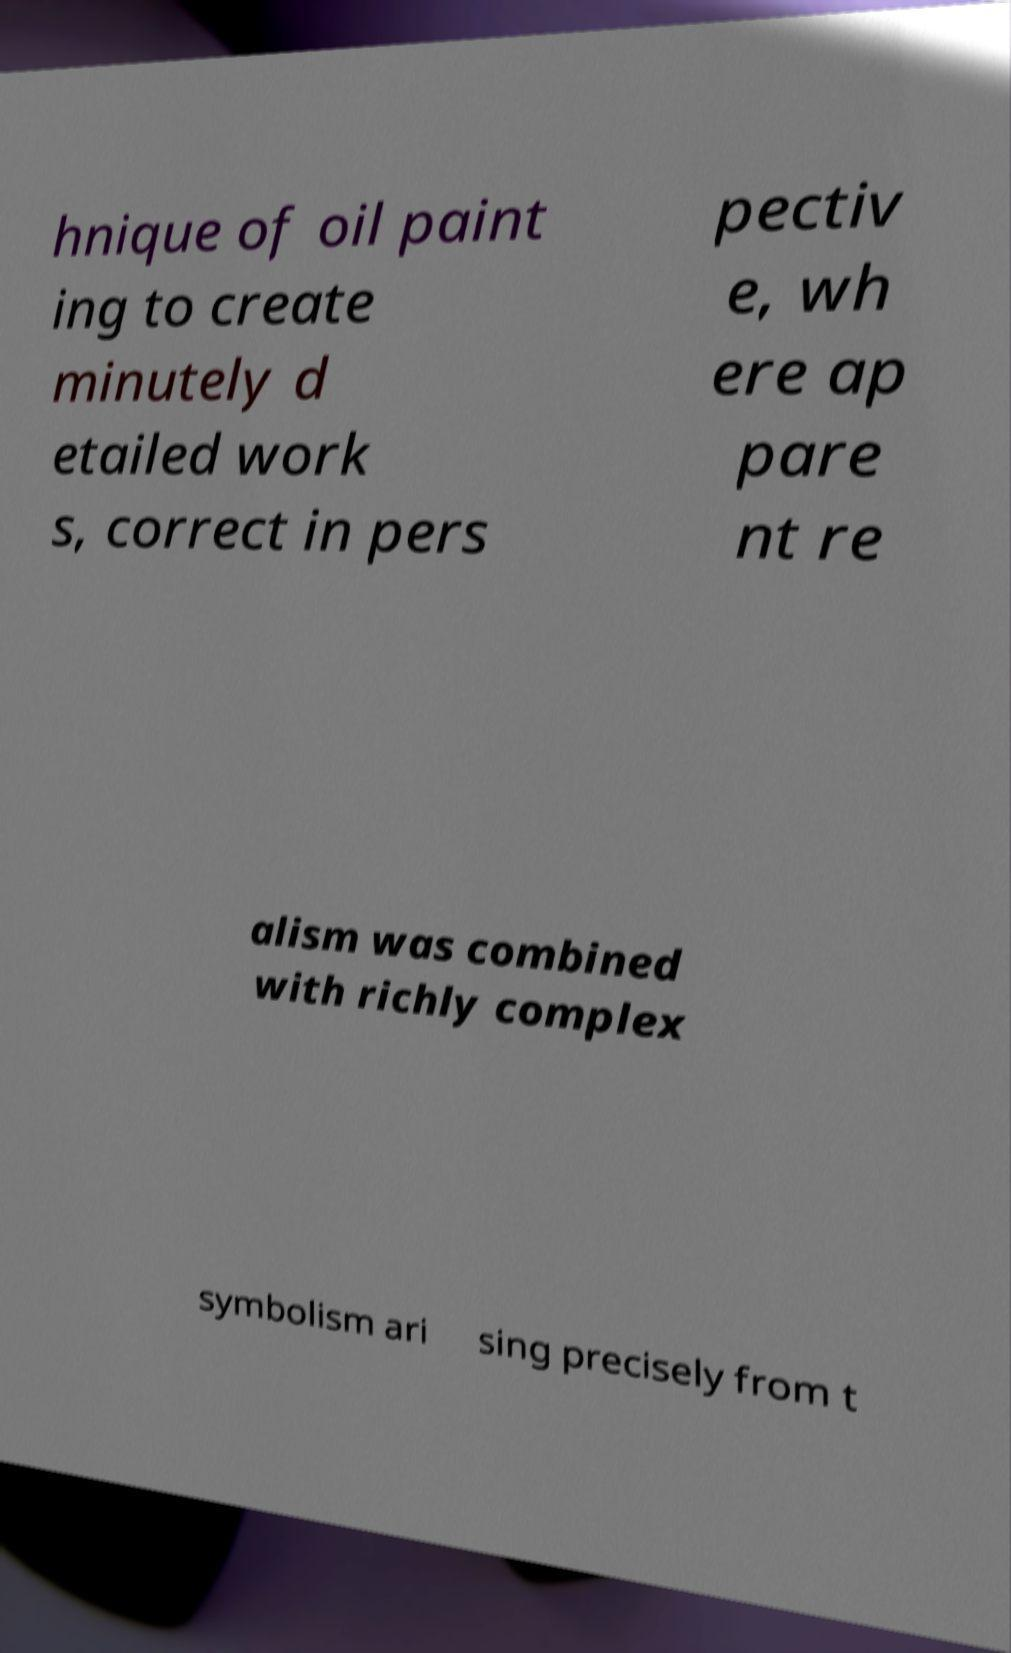Could you extract and type out the text from this image? hnique of oil paint ing to create minutely d etailed work s, correct in pers pectiv e, wh ere ap pare nt re alism was combined with richly complex symbolism ari sing precisely from t 